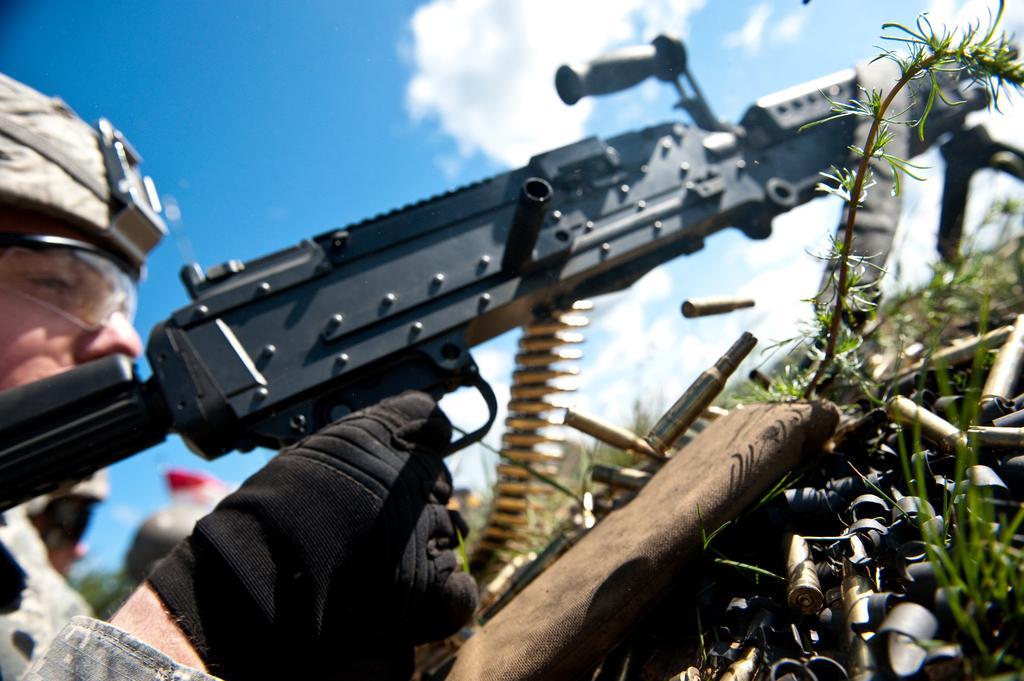Describe this image in one or two sentences. In this image I can see a person holding gun and wearing military dress and black color glove. I can see green grass. The sky is in white and blue color. 